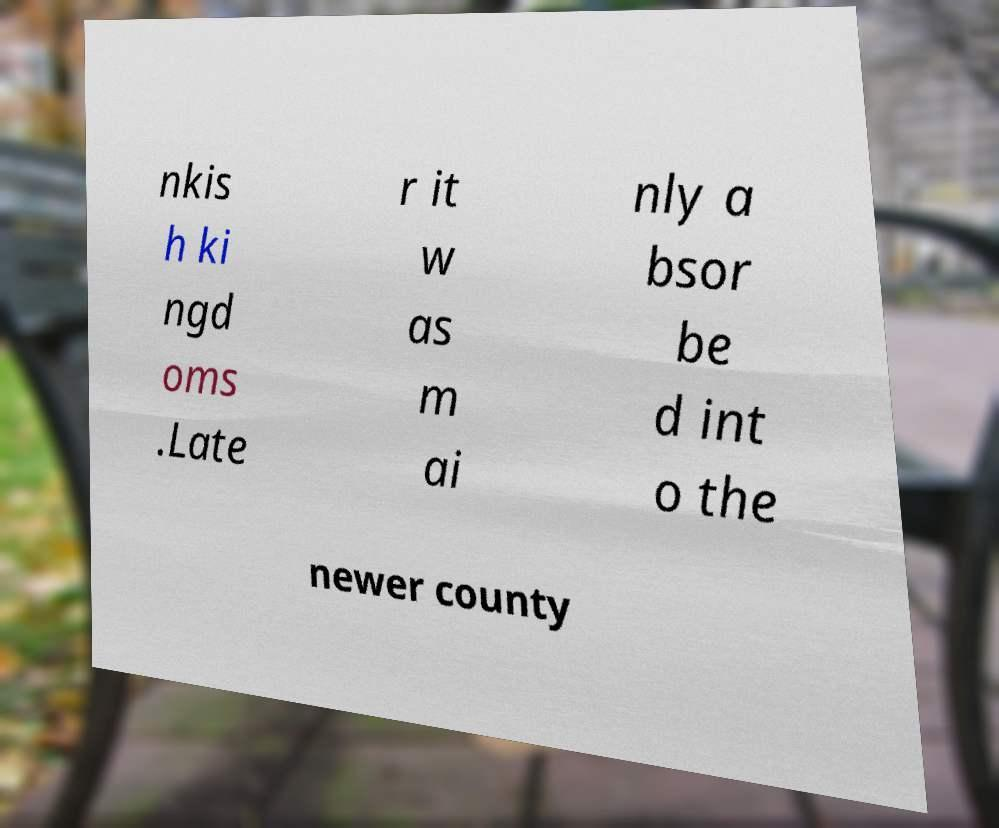What messages or text are displayed in this image? I need them in a readable, typed format. nkis h ki ngd oms .Late r it w as m ai nly a bsor be d int o the newer county 